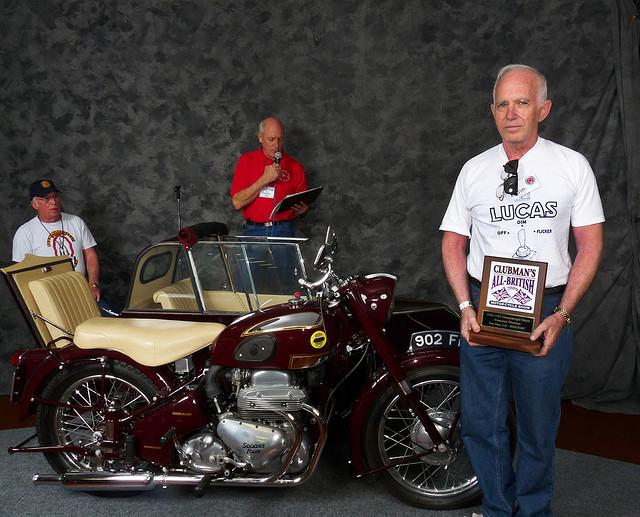Why is the man holding a microphone? amplify voice 